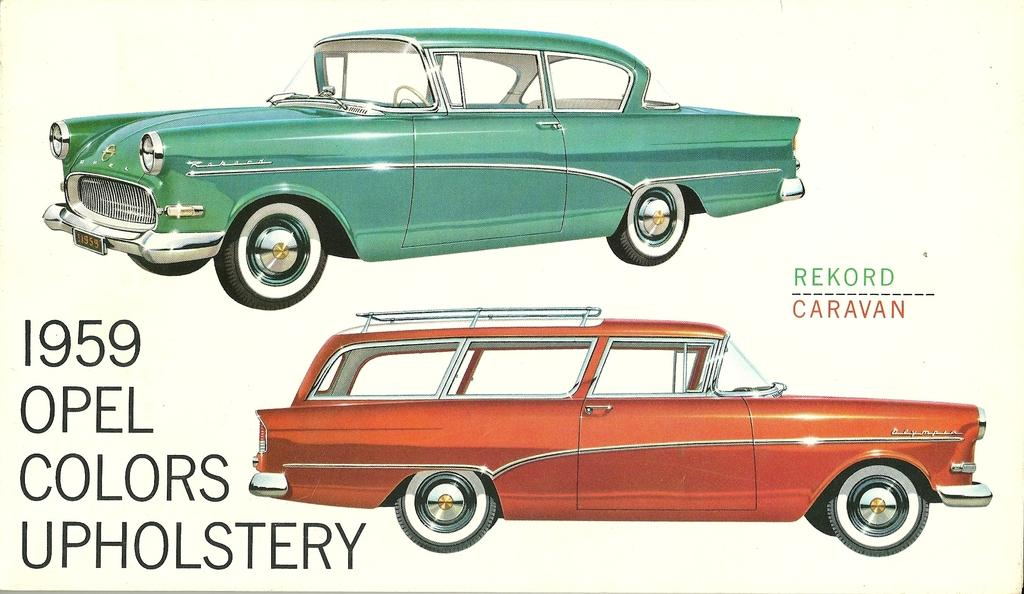What is featured on the poster in the image? There is a poster in the image, and it contains pictures of vehicles. What else can be seen on the poster besides the pictures of vehicles? There is text on the poster. What type of baseball equipment can be seen in the image? There is no baseball equipment present in the image; it features a poster with pictures of vehicles. What direction is the poster facing in the image? The direction the poster is facing cannot be determined from the image. 